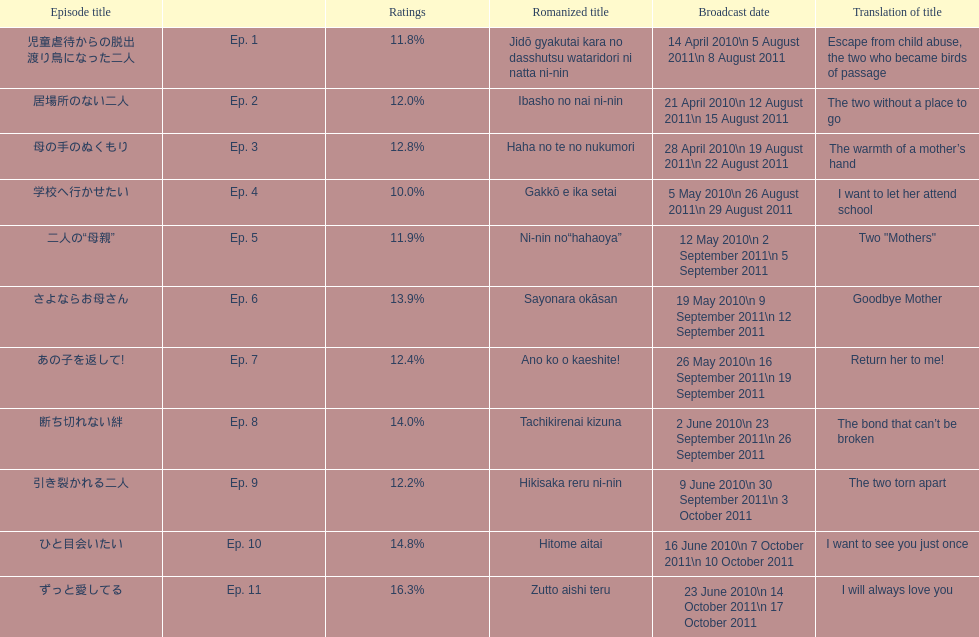Other than the 10th episode, which other episode has a 14% rating? Ep. 8. 